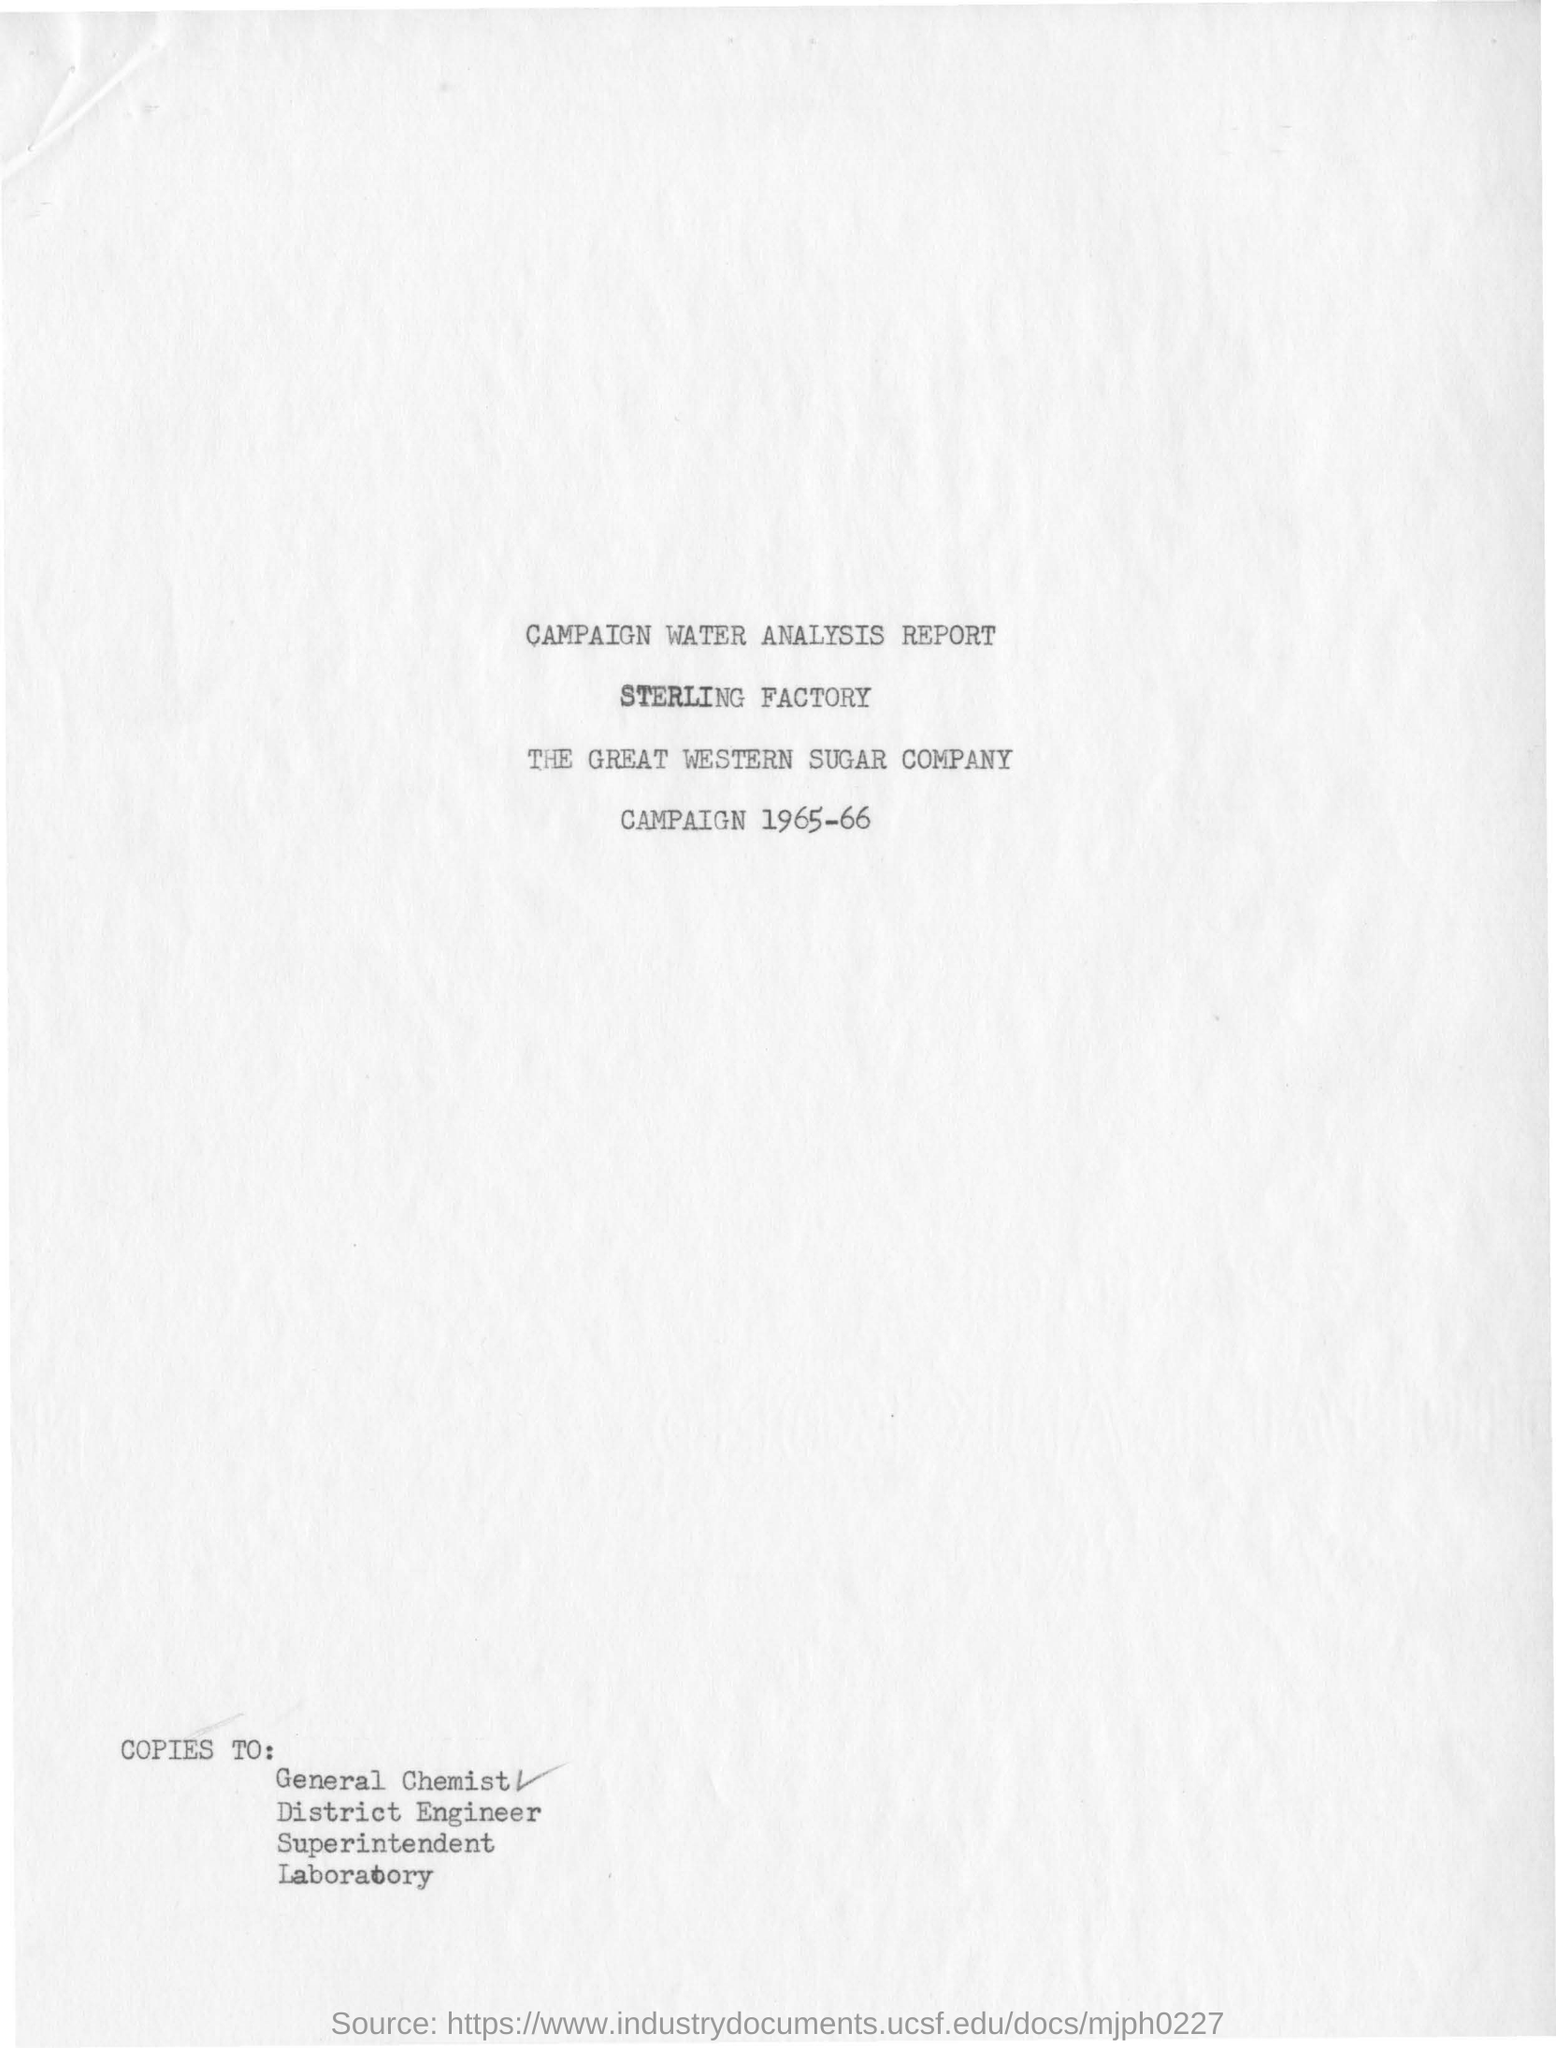What is the name of the factory ?
Give a very brief answer. Sterling factory. What is the name of the company ?
Make the answer very short. THE GREAT WESTERN SUGAR COMPANY. In which years the campaign has done ?
Keep it short and to the point. Campaign 1965-66. 